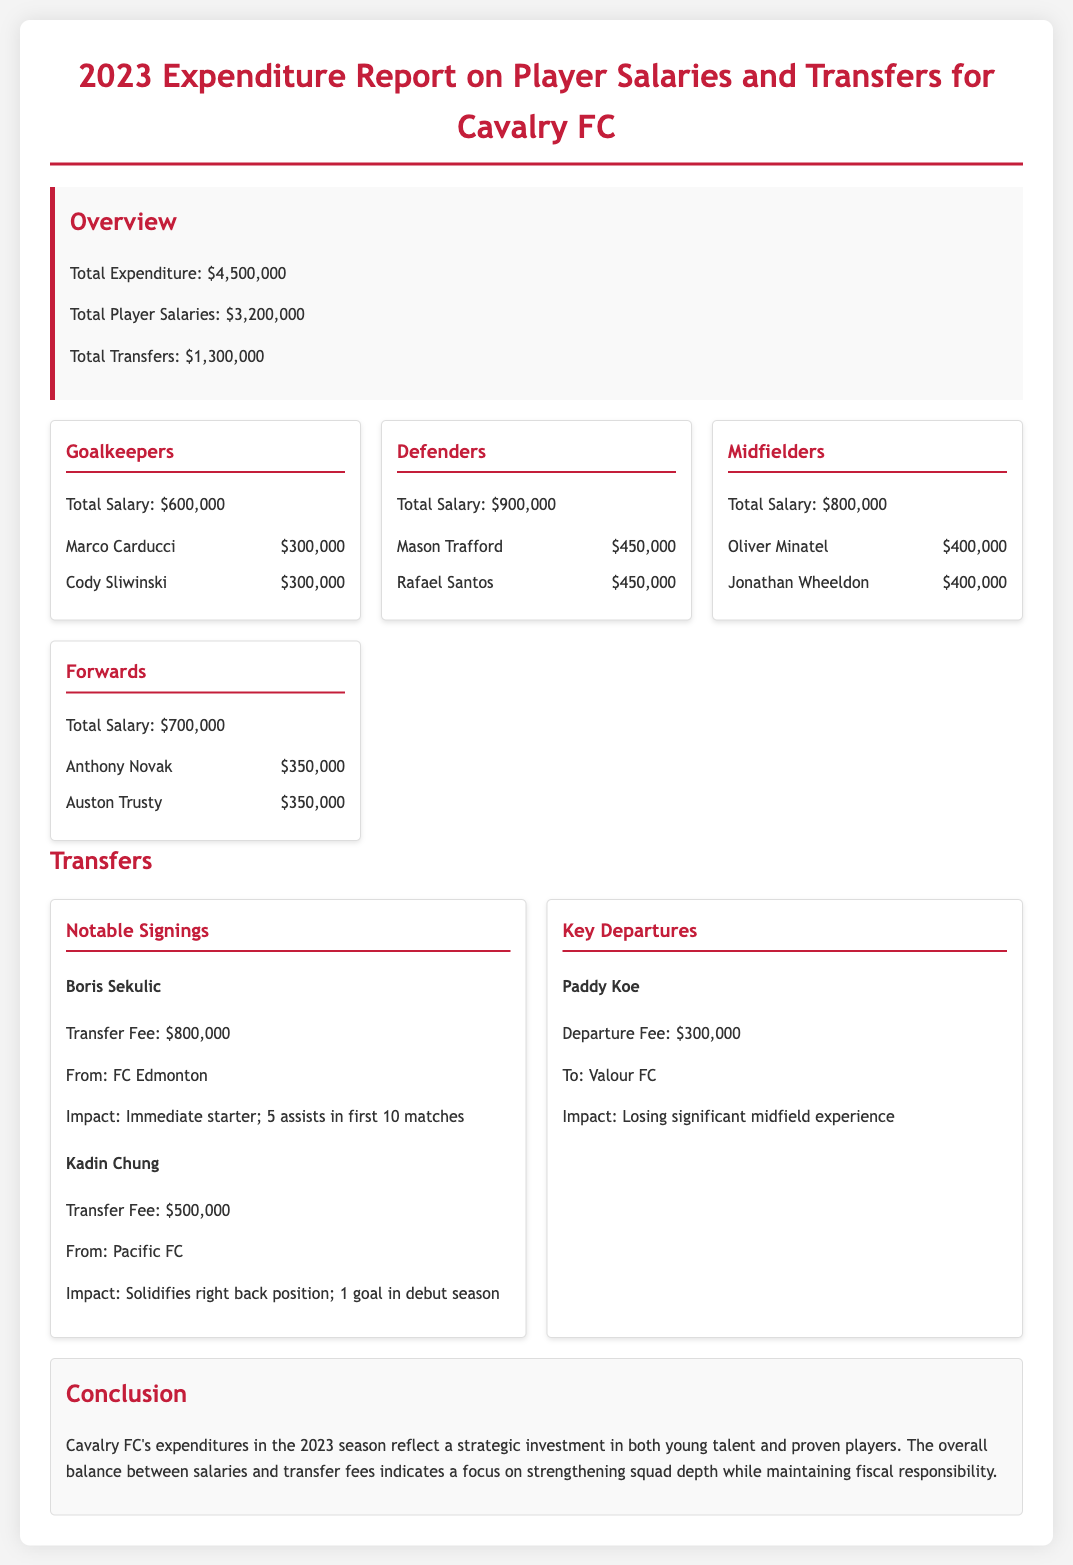What is the total expenditure? The total expenditure is listed in the document as $4,500,000.
Answer: $4,500,000 What is the total salary for goalkeepers? The document shows that the total salary for goalkeepers is $600,000.
Answer: $600,000 Who is the highest-paid defender? Mason Trafford and Rafael Santos both earn $450,000; they are the highest-paid defenders.
Answer: Mason Trafford / Rafael Santos What was the transfer fee for Boris Sekulic? The document states that Boris Sekulic's transfer fee was $800,000.
Answer: $800,000 What is the impact of Kadin Chung's signing? The document notes that Kadin Chung solidifies the right back position with 1 goal in his debut season.
Answer: Solidifies right back position; 1 goal in debut season How much was received from the departure of Paddy Koe? The departure fee for Paddy Koe is recorded as $300,000 in the document.
Answer: $300,000 What percentage of total expenditure is allocated to player salaries? To find this, calculate ($3,200,000 / $4,500,000) * 100, which gives approximately 71.1%.
Answer: 71.1% What is the total salary for forwards? The document indicates that the total salary for forwards is $700,000.
Answer: $700,000 What is the conclusion of the report? The conclusion reflects a strategic investment in young talent and proven players with focus on fiscal responsibility.
Answer: Strategic investment in young talent and proven players 